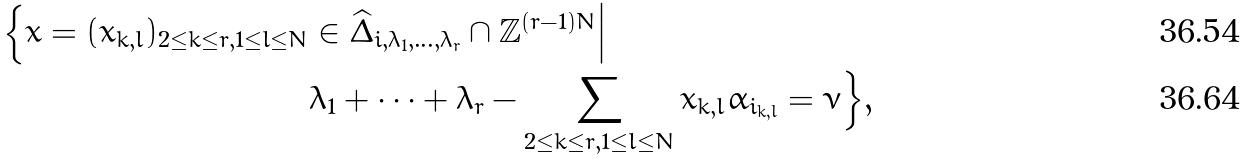Convert formula to latex. <formula><loc_0><loc_0><loc_500><loc_500>\Big \{ { x } = ( x _ { k , l } ) _ { 2 \leq k \leq r , 1 \leq l \leq N } & \in \widehat { \Delta } _ { { i } , \lambda _ { 1 } , \dots , \lambda _ { r } } \cap \mathbb { Z } ^ { ( r - 1 ) N } \Big | \\ & \lambda _ { 1 } + \cdots + \lambda _ { r } - \sum _ { 2 \leq k \leq r , 1 \leq l \leq N } x _ { k , l } \alpha _ { i _ { k , l } } = \nu \Big \} ,</formula> 